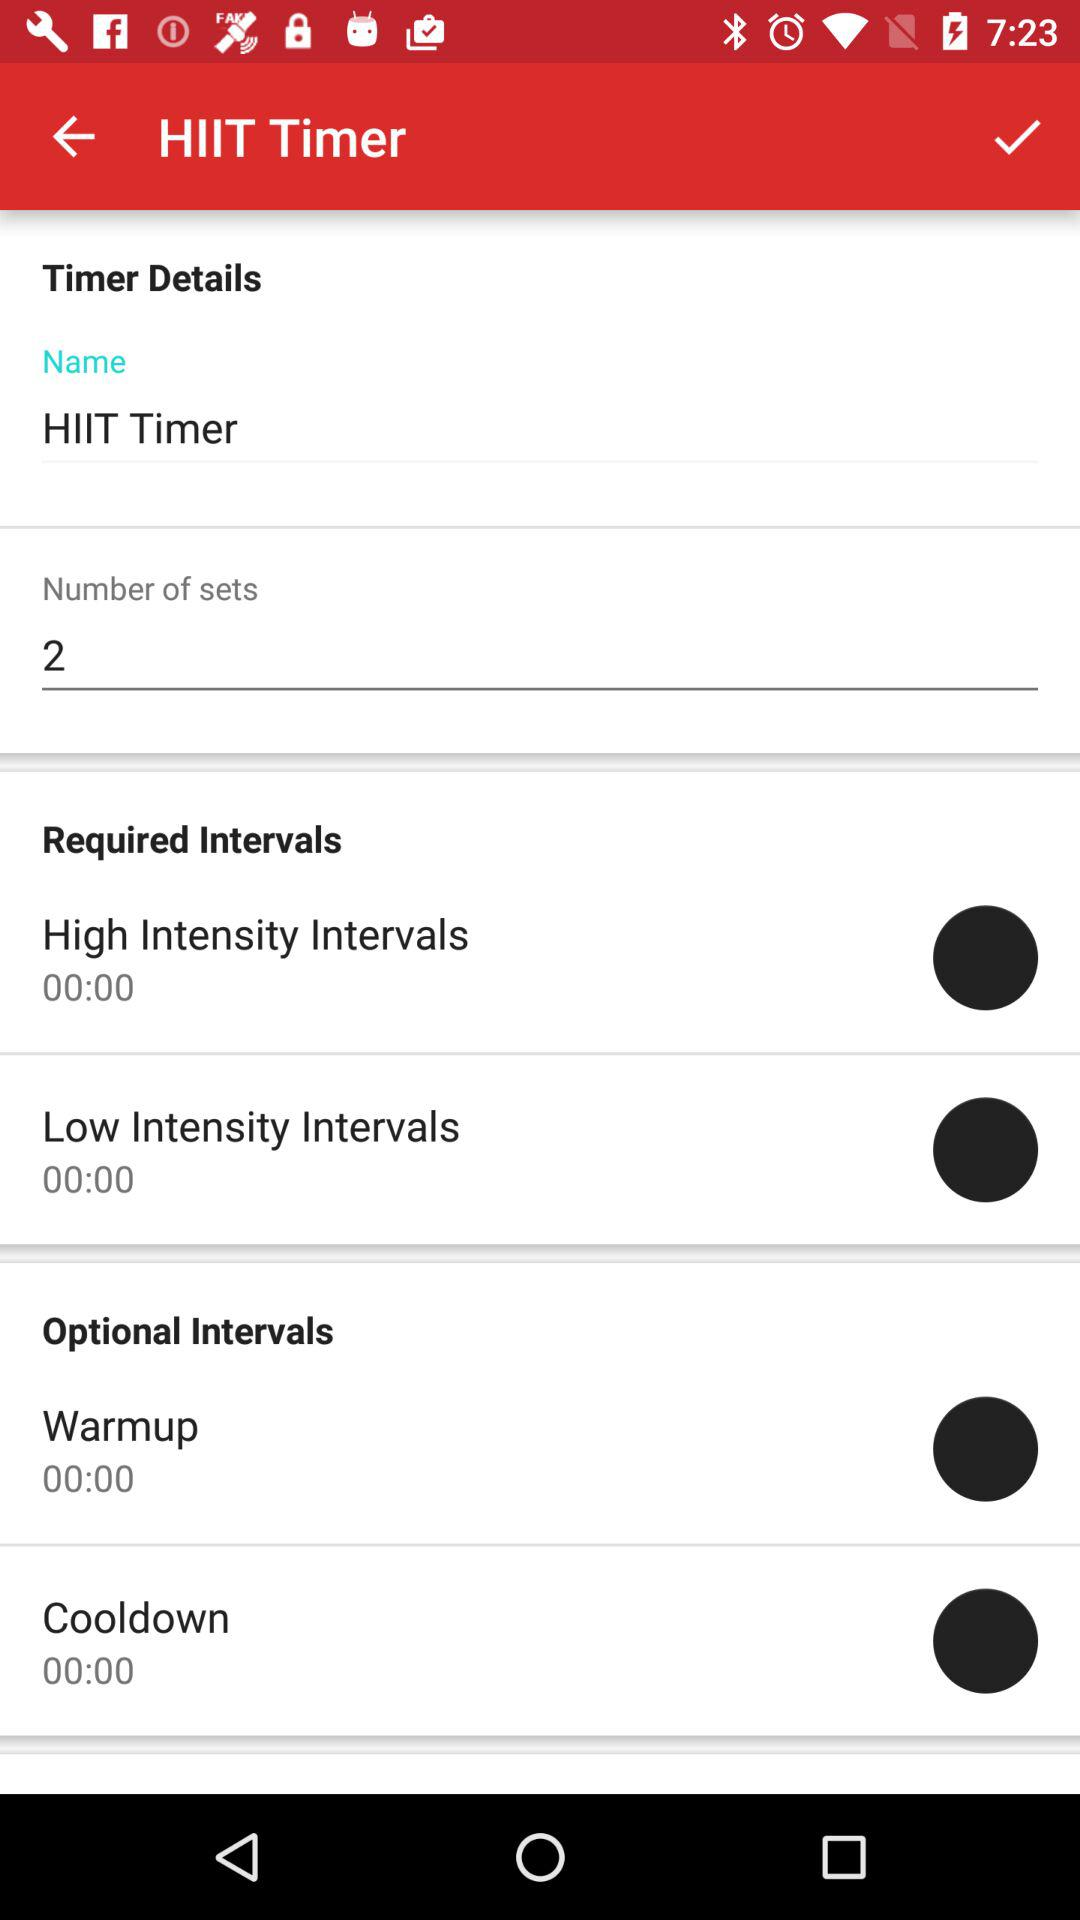What is the name of the timer? The timer name is "HIIT Timer". 